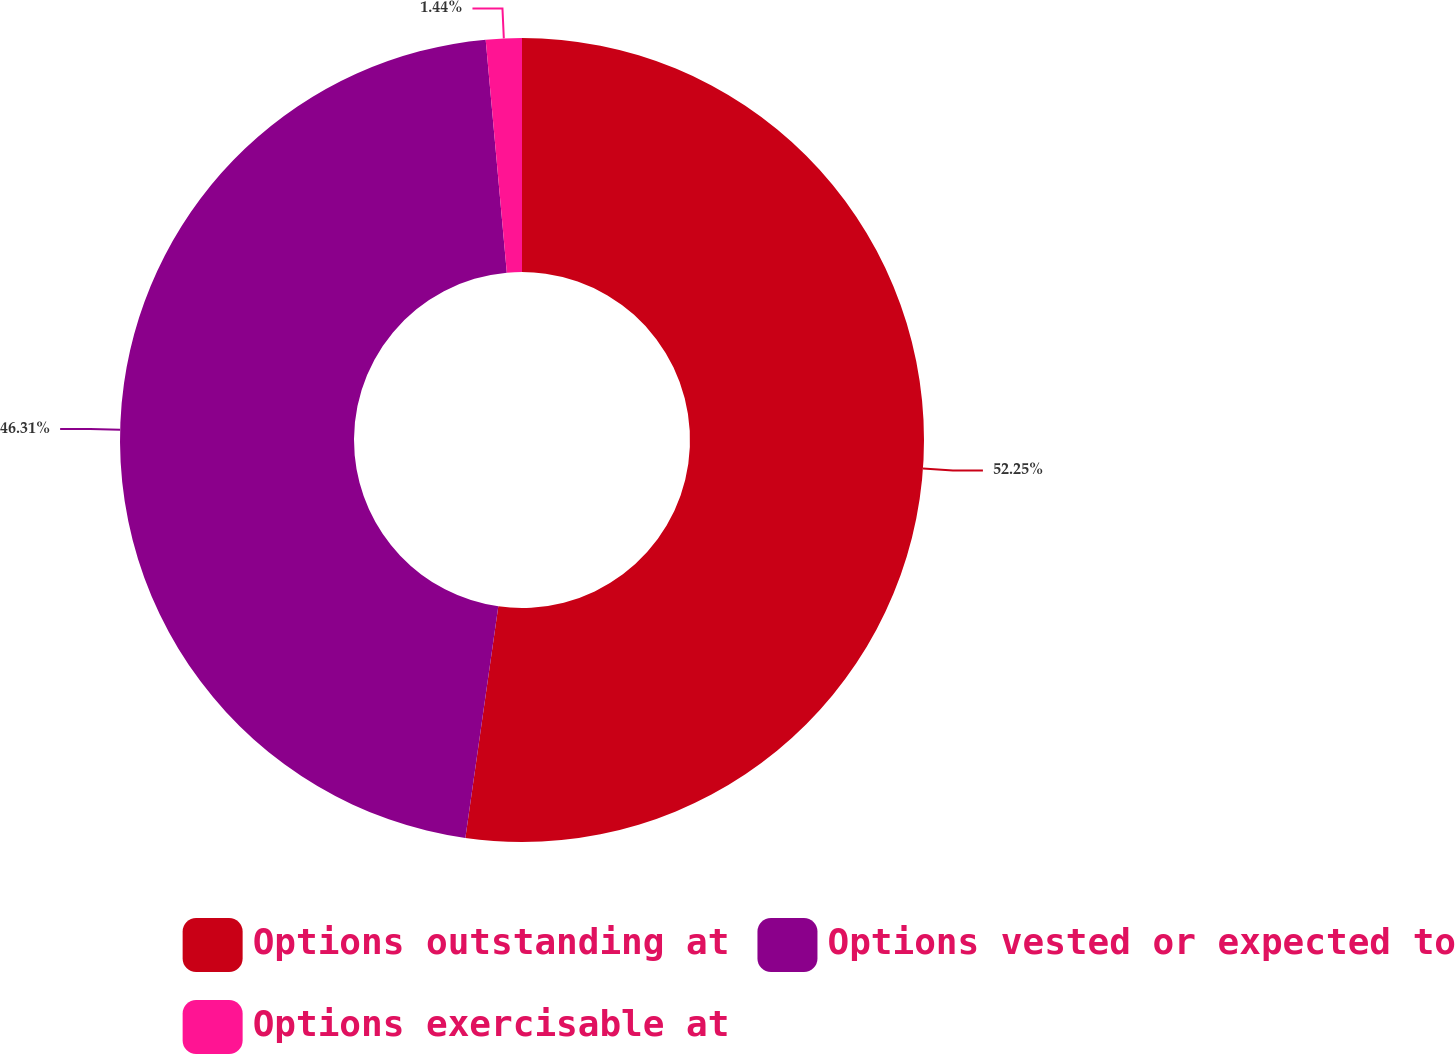Convert chart to OTSL. <chart><loc_0><loc_0><loc_500><loc_500><pie_chart><fcel>Options outstanding at<fcel>Options vested or expected to<fcel>Options exercisable at<nl><fcel>52.25%<fcel>46.31%<fcel>1.44%<nl></chart> 